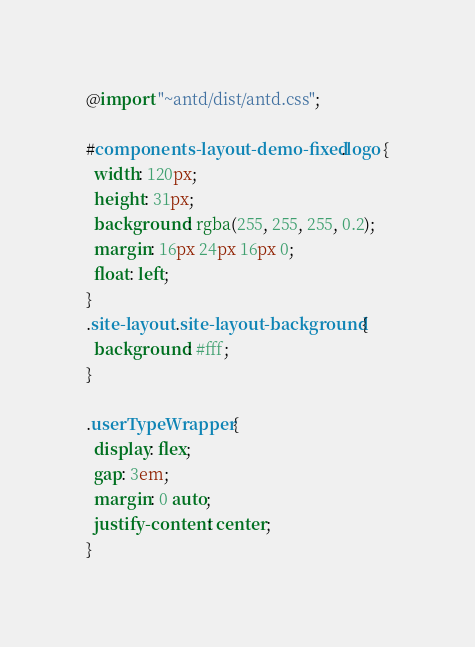<code> <loc_0><loc_0><loc_500><loc_500><_CSS_>@import "~antd/dist/antd.css";

#components-layout-demo-fixed .logo {
  width: 120px;
  height: 31px;
  background: rgba(255, 255, 255, 0.2);
  margin: 16px 24px 16px 0;
  float: left;
}
.site-layout .site-layout-background {
  background: #fff;
}

.userTypeWrapper {
  display: flex;
  gap: 3em;
  margin: 0 auto;
  justify-content: center;
}
</code> 